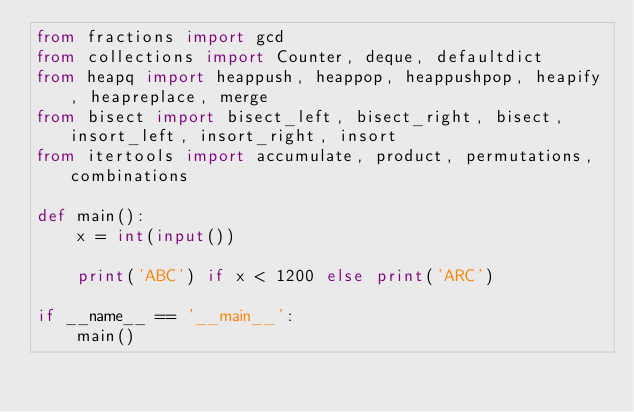Convert code to text. <code><loc_0><loc_0><loc_500><loc_500><_Python_>from fractions import gcd
from collections import Counter, deque, defaultdict
from heapq import heappush, heappop, heappushpop, heapify, heapreplace, merge
from bisect import bisect_left, bisect_right, bisect, insort_left, insort_right, insort
from itertools import accumulate, product, permutations, combinations

def main():
    x = int(input())

    print('ABC') if x < 1200 else print('ARC')

if __name__ == '__main__':
    main()</code> 